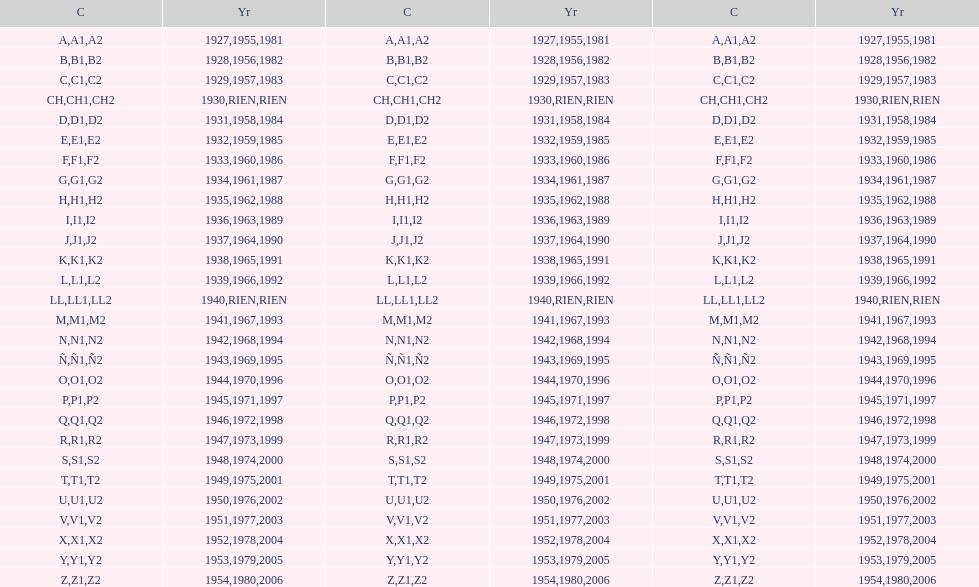Is the e-code below 1950? Yes. 